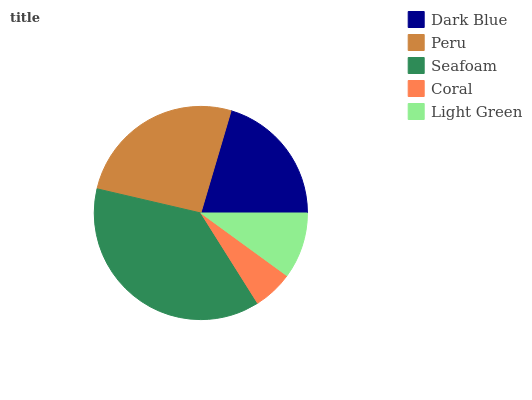Is Coral the minimum?
Answer yes or no. Yes. Is Seafoam the maximum?
Answer yes or no. Yes. Is Peru the minimum?
Answer yes or no. No. Is Peru the maximum?
Answer yes or no. No. Is Peru greater than Dark Blue?
Answer yes or no. Yes. Is Dark Blue less than Peru?
Answer yes or no. Yes. Is Dark Blue greater than Peru?
Answer yes or no. No. Is Peru less than Dark Blue?
Answer yes or no. No. Is Dark Blue the high median?
Answer yes or no. Yes. Is Dark Blue the low median?
Answer yes or no. Yes. Is Peru the high median?
Answer yes or no. No. Is Light Green the low median?
Answer yes or no. No. 